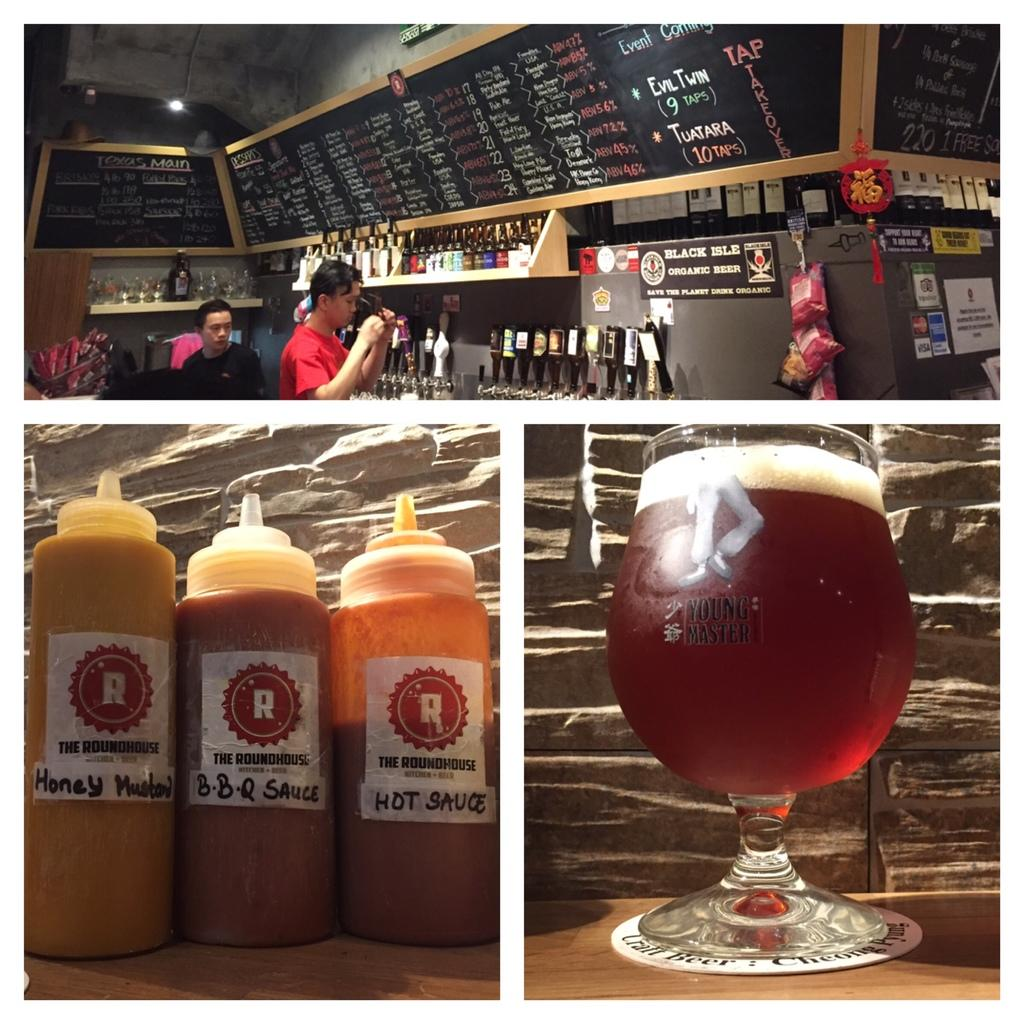Provide a one-sentence caption for the provided image. Drink and sauces, honey mustard, bbq sauce and hot sauce offered at this bar. 